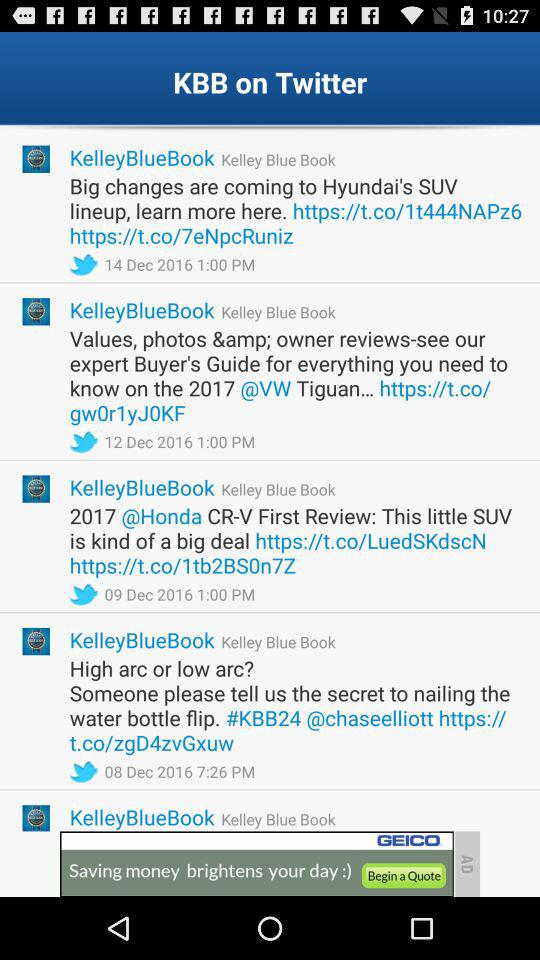The prices are given for what item? The prices are given for 2017 Acura ILX. 